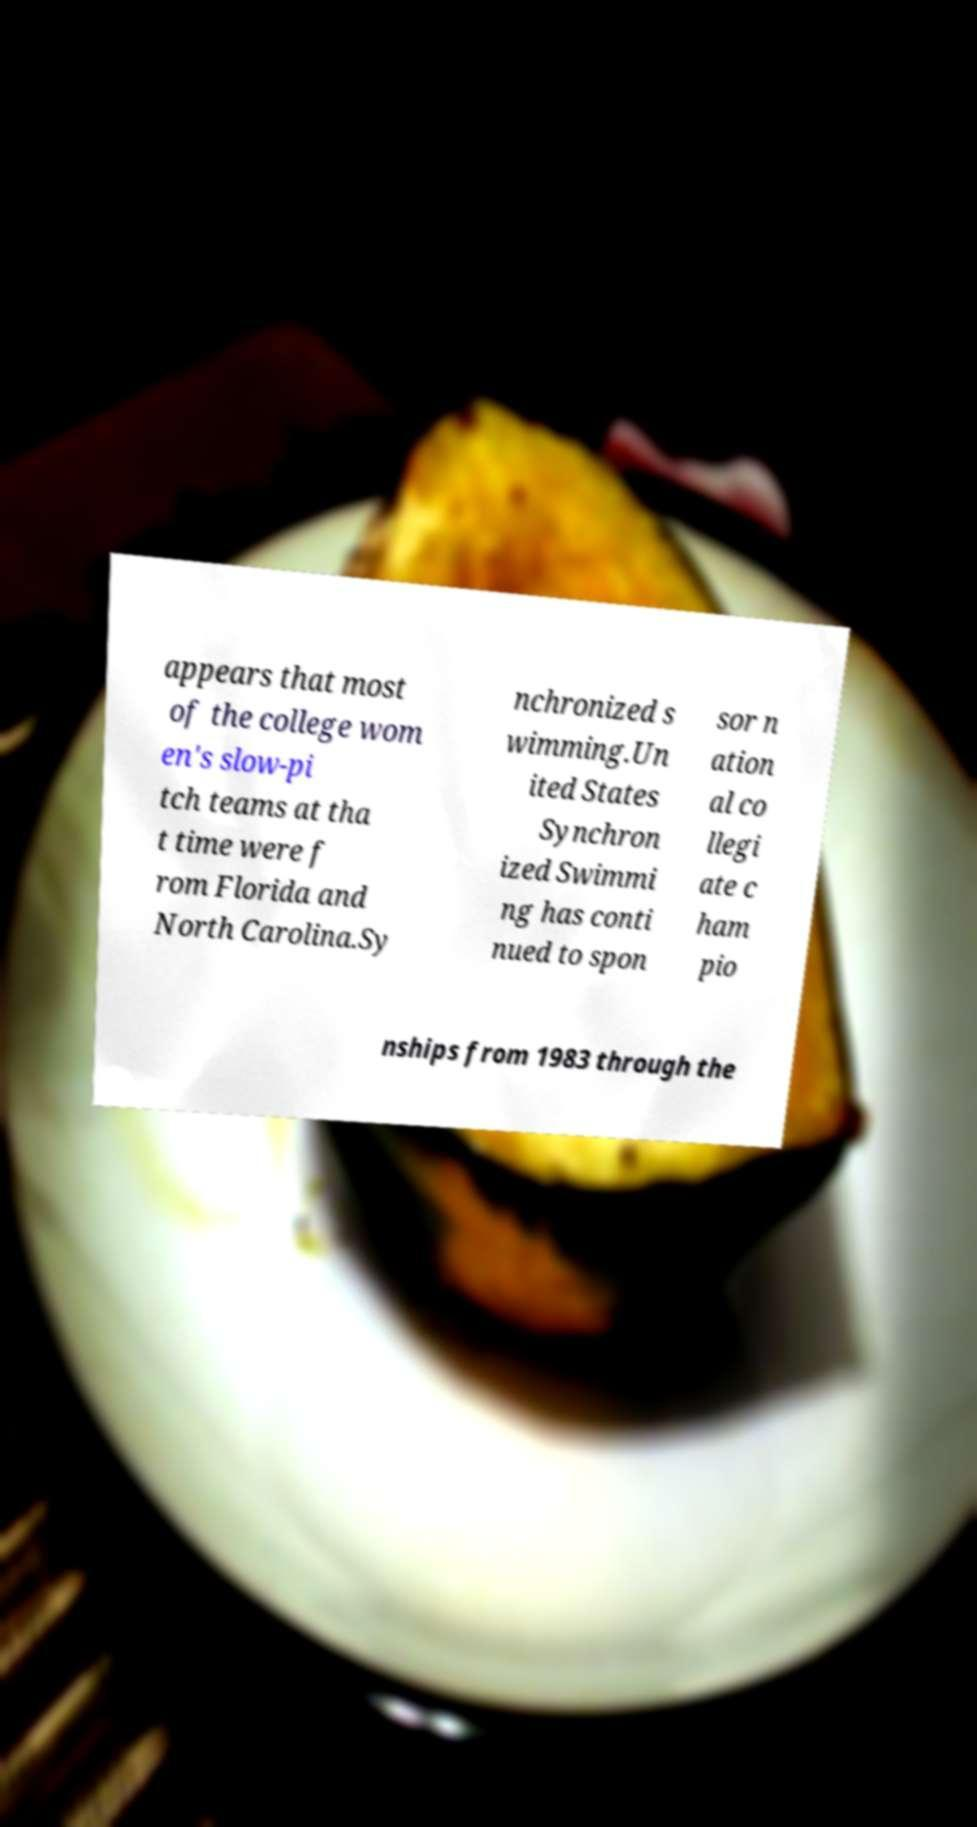For documentation purposes, I need the text within this image transcribed. Could you provide that? appears that most of the college wom en's slow-pi tch teams at tha t time were f rom Florida and North Carolina.Sy nchronized s wimming.Un ited States Synchron ized Swimmi ng has conti nued to spon sor n ation al co llegi ate c ham pio nships from 1983 through the 